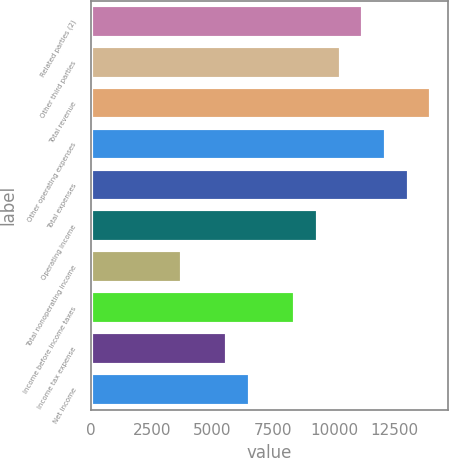Convert chart. <chart><loc_0><loc_0><loc_500><loc_500><bar_chart><fcel>Related parties (2)<fcel>Other third parties<fcel>Total revenue<fcel>Other operating expenses<fcel>Total expenses<fcel>Operating income<fcel>Total nonoperating income<fcel>Income before income taxes<fcel>Income tax expense<fcel>Net income<nl><fcel>11203.2<fcel>10270.1<fcel>14002.5<fcel>12136.3<fcel>13069.4<fcel>9337<fcel>3738.4<fcel>8403.9<fcel>5604.6<fcel>6537.7<nl></chart> 